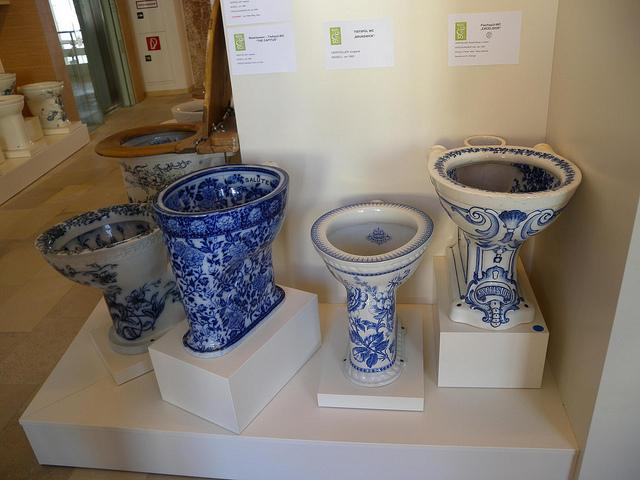Where would this style of porcelain item be found in a house?

Choices:
A) kitchen
B) laundry room
C) bathroom
D) garage bathroom 